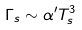<formula> <loc_0><loc_0><loc_500><loc_500>\Gamma _ { s } \sim \alpha ^ { \prime } T _ { s } ^ { 3 }</formula> 